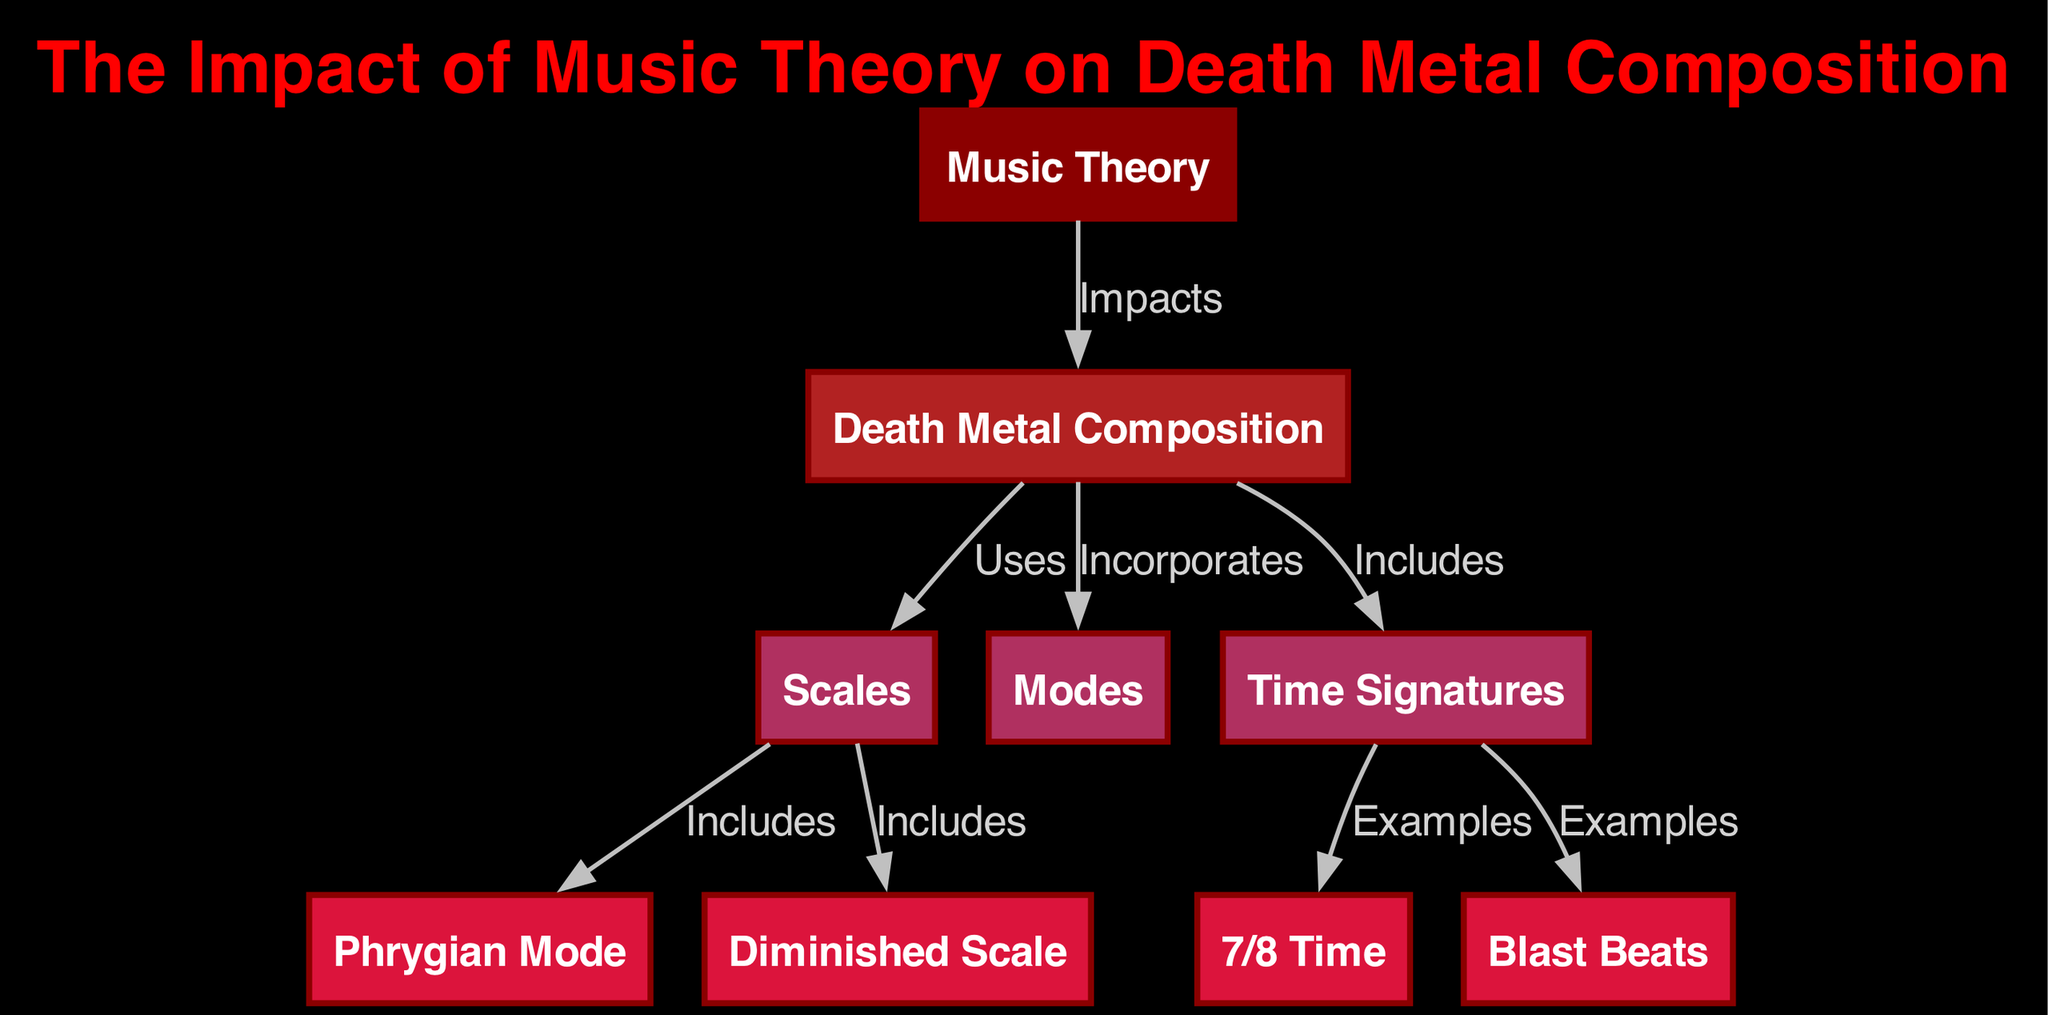What is the total number of nodes in the diagram? The diagram contains eight distinct nodes as identified in the list of nodes: Music Theory, Death Metal Composition, Scales, Modes, Time Signatures, Phrygian Mode, Diminished Scale, and 7/8 Time. Counting these, the total comes to eight.
Answer: 8 Which mode is included under scales? The diagram specifically indicates that the Phrygian Mode is included as a subtype of scales, as shown by the directed edge from Scales to Phrygian Mode labelled "Includes".
Answer: Phrygian Mode What type of relationship exists between Music Theory and Death Metal Composition? The diagram shows a directed edge labelled "Impacts" from Music Theory to Death Metal Composition, indicating that the first contributes effects or influences the latter.
Answer: Impacts How many examples of time signatures are provided? The diagram provides two examples under the category of Time Signatures, highlighted by the edges leading from Time Signatures to 7/8 Time and Blast Beats. Thus, there are two examples listed.
Answer: 2 Which scale is included under scales apart from modes? The diagram shows that the Diminished Scale is another inclusion under the category of scales, as indicated by the edge from Scales to Diminished Scale labelled "Includes".
Answer: Diminished Scale What does Death Metal Composition incorporate according to the diagram? According to the diagram, Death Metal Composition incorporates both Scales and Modes, as two edges are drawn from Death Metal Composition to these respective nodes with the label "Incorporates".
Answer: Scales, Modes What is an example of a specific time signature used in death metal? The diagram lists 7/8 Time as a specific example of a time signature, which is noted by the edge from Time Signatures showing the relationship.
Answer: 7/8 Time What type of beats are noted as an example under time signatures? The diagram has a path leading from Time Signatures to Blast Beats, indicating that Blast Beats are another example used within time signatures, thus capturing a common rhythm in Death Metal.
Answer: Blast Beats 